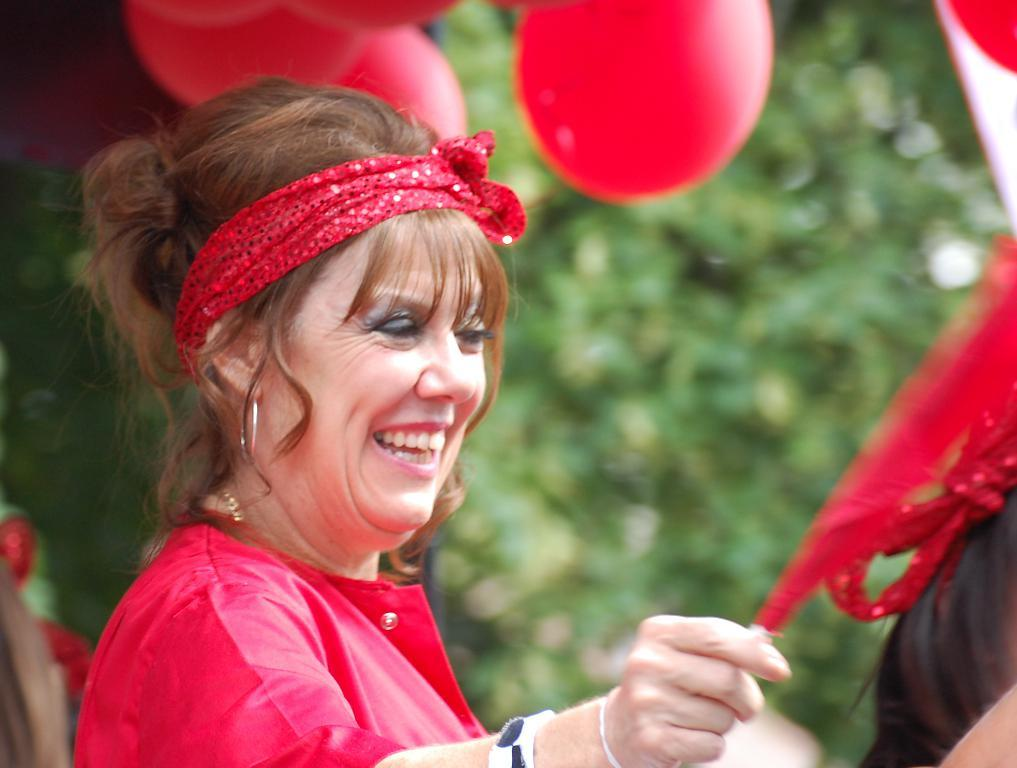Who is present in the image? There is a person in the image. What is the person wearing? The person is wearing a red dress. What can be seen in the background of the image? There are red color balloons and green color trees in the background. What type of punishment is being administered to the person in the image? There is no indication of punishment in the image; the person is simply wearing a red dress and standing in front of red balloons and green trees. 